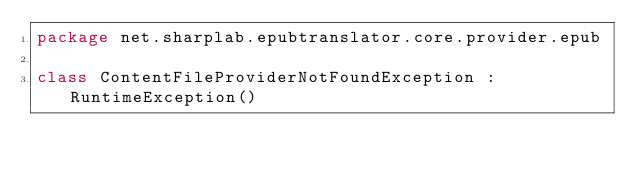<code> <loc_0><loc_0><loc_500><loc_500><_Kotlin_>package net.sharplab.epubtranslator.core.provider.epub

class ContentFileProviderNotFoundException : RuntimeException()</code> 